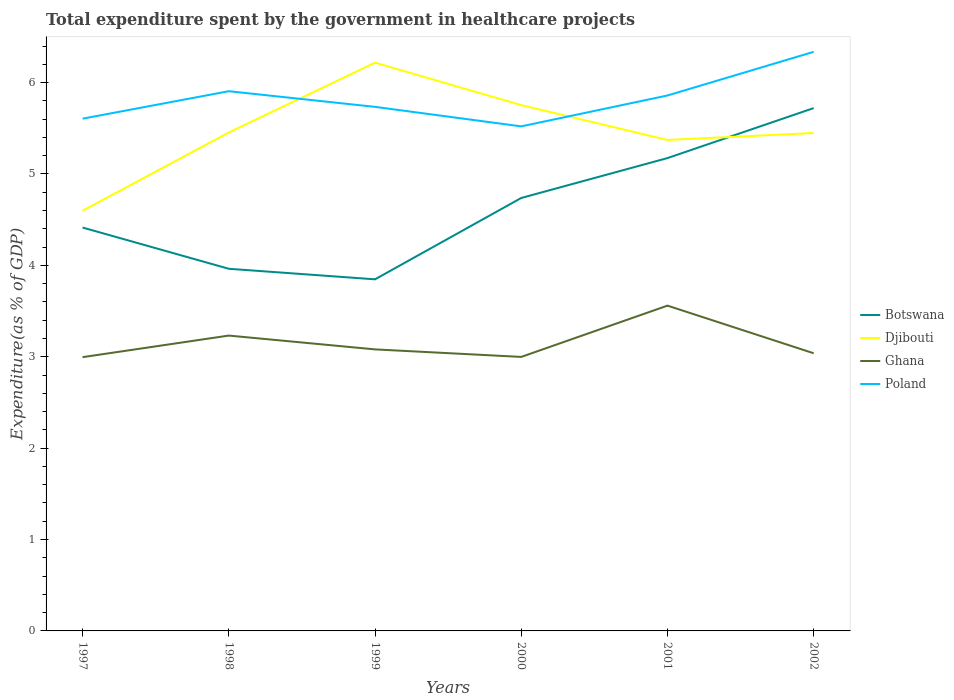How many different coloured lines are there?
Ensure brevity in your answer.  4. Does the line corresponding to Djibouti intersect with the line corresponding to Ghana?
Give a very brief answer. No. Is the number of lines equal to the number of legend labels?
Make the answer very short. Yes. Across all years, what is the maximum total expenditure spent by the government in healthcare projects in Ghana?
Provide a short and direct response. 3. In which year was the total expenditure spent by the government in healthcare projects in Poland maximum?
Your answer should be compact. 2000. What is the total total expenditure spent by the government in healthcare projects in Poland in the graph?
Make the answer very short. 0.21. What is the difference between the highest and the second highest total expenditure spent by the government in healthcare projects in Ghana?
Make the answer very short. 0.56. What is the difference between the highest and the lowest total expenditure spent by the government in healthcare projects in Ghana?
Make the answer very short. 2. Is the total expenditure spent by the government in healthcare projects in Ghana strictly greater than the total expenditure spent by the government in healthcare projects in Poland over the years?
Give a very brief answer. Yes. How many lines are there?
Give a very brief answer. 4. How many legend labels are there?
Provide a short and direct response. 4. How are the legend labels stacked?
Provide a short and direct response. Vertical. What is the title of the graph?
Keep it short and to the point. Total expenditure spent by the government in healthcare projects. Does "St. Vincent and the Grenadines" appear as one of the legend labels in the graph?
Your answer should be very brief. No. What is the label or title of the X-axis?
Make the answer very short. Years. What is the label or title of the Y-axis?
Give a very brief answer. Expenditure(as % of GDP). What is the Expenditure(as % of GDP) of Botswana in 1997?
Offer a terse response. 4.41. What is the Expenditure(as % of GDP) of Djibouti in 1997?
Ensure brevity in your answer.  4.6. What is the Expenditure(as % of GDP) in Ghana in 1997?
Give a very brief answer. 3. What is the Expenditure(as % of GDP) in Poland in 1997?
Make the answer very short. 5.61. What is the Expenditure(as % of GDP) of Botswana in 1998?
Your response must be concise. 3.96. What is the Expenditure(as % of GDP) in Djibouti in 1998?
Offer a very short reply. 5.45. What is the Expenditure(as % of GDP) of Ghana in 1998?
Your answer should be compact. 3.23. What is the Expenditure(as % of GDP) in Poland in 1998?
Make the answer very short. 5.91. What is the Expenditure(as % of GDP) of Botswana in 1999?
Offer a terse response. 3.85. What is the Expenditure(as % of GDP) of Djibouti in 1999?
Offer a terse response. 6.22. What is the Expenditure(as % of GDP) of Ghana in 1999?
Offer a terse response. 3.08. What is the Expenditure(as % of GDP) in Poland in 1999?
Offer a terse response. 5.73. What is the Expenditure(as % of GDP) in Botswana in 2000?
Provide a succinct answer. 4.74. What is the Expenditure(as % of GDP) of Djibouti in 2000?
Ensure brevity in your answer.  5.75. What is the Expenditure(as % of GDP) of Ghana in 2000?
Your answer should be compact. 3. What is the Expenditure(as % of GDP) of Poland in 2000?
Your answer should be compact. 5.52. What is the Expenditure(as % of GDP) in Botswana in 2001?
Your answer should be very brief. 5.17. What is the Expenditure(as % of GDP) in Djibouti in 2001?
Your response must be concise. 5.37. What is the Expenditure(as % of GDP) of Ghana in 2001?
Your answer should be compact. 3.56. What is the Expenditure(as % of GDP) of Poland in 2001?
Provide a succinct answer. 5.86. What is the Expenditure(as % of GDP) of Botswana in 2002?
Make the answer very short. 5.72. What is the Expenditure(as % of GDP) in Djibouti in 2002?
Provide a succinct answer. 5.45. What is the Expenditure(as % of GDP) of Ghana in 2002?
Offer a terse response. 3.04. What is the Expenditure(as % of GDP) in Poland in 2002?
Your response must be concise. 6.34. Across all years, what is the maximum Expenditure(as % of GDP) in Botswana?
Offer a terse response. 5.72. Across all years, what is the maximum Expenditure(as % of GDP) in Djibouti?
Provide a short and direct response. 6.22. Across all years, what is the maximum Expenditure(as % of GDP) of Ghana?
Give a very brief answer. 3.56. Across all years, what is the maximum Expenditure(as % of GDP) of Poland?
Ensure brevity in your answer.  6.34. Across all years, what is the minimum Expenditure(as % of GDP) of Botswana?
Give a very brief answer. 3.85. Across all years, what is the minimum Expenditure(as % of GDP) of Djibouti?
Provide a short and direct response. 4.6. Across all years, what is the minimum Expenditure(as % of GDP) in Ghana?
Offer a terse response. 3. Across all years, what is the minimum Expenditure(as % of GDP) in Poland?
Make the answer very short. 5.52. What is the total Expenditure(as % of GDP) of Botswana in the graph?
Provide a short and direct response. 27.86. What is the total Expenditure(as % of GDP) of Djibouti in the graph?
Provide a short and direct response. 32.85. What is the total Expenditure(as % of GDP) in Ghana in the graph?
Offer a very short reply. 18.9. What is the total Expenditure(as % of GDP) of Poland in the graph?
Offer a terse response. 34.96. What is the difference between the Expenditure(as % of GDP) in Botswana in 1997 and that in 1998?
Keep it short and to the point. 0.45. What is the difference between the Expenditure(as % of GDP) of Djibouti in 1997 and that in 1998?
Make the answer very short. -0.86. What is the difference between the Expenditure(as % of GDP) in Ghana in 1997 and that in 1998?
Provide a short and direct response. -0.24. What is the difference between the Expenditure(as % of GDP) of Poland in 1997 and that in 1998?
Keep it short and to the point. -0.3. What is the difference between the Expenditure(as % of GDP) in Botswana in 1997 and that in 1999?
Offer a terse response. 0.57. What is the difference between the Expenditure(as % of GDP) in Djibouti in 1997 and that in 1999?
Provide a short and direct response. -1.62. What is the difference between the Expenditure(as % of GDP) in Ghana in 1997 and that in 1999?
Your answer should be very brief. -0.08. What is the difference between the Expenditure(as % of GDP) of Poland in 1997 and that in 1999?
Offer a terse response. -0.13. What is the difference between the Expenditure(as % of GDP) in Botswana in 1997 and that in 2000?
Offer a very short reply. -0.32. What is the difference between the Expenditure(as % of GDP) in Djibouti in 1997 and that in 2000?
Offer a terse response. -1.16. What is the difference between the Expenditure(as % of GDP) of Ghana in 1997 and that in 2000?
Provide a short and direct response. -0. What is the difference between the Expenditure(as % of GDP) of Poland in 1997 and that in 2000?
Make the answer very short. 0.08. What is the difference between the Expenditure(as % of GDP) in Botswana in 1997 and that in 2001?
Your answer should be compact. -0.76. What is the difference between the Expenditure(as % of GDP) in Djibouti in 1997 and that in 2001?
Ensure brevity in your answer.  -0.77. What is the difference between the Expenditure(as % of GDP) in Ghana in 1997 and that in 2001?
Offer a very short reply. -0.56. What is the difference between the Expenditure(as % of GDP) of Poland in 1997 and that in 2001?
Give a very brief answer. -0.25. What is the difference between the Expenditure(as % of GDP) in Botswana in 1997 and that in 2002?
Provide a short and direct response. -1.31. What is the difference between the Expenditure(as % of GDP) of Djibouti in 1997 and that in 2002?
Your response must be concise. -0.85. What is the difference between the Expenditure(as % of GDP) of Ghana in 1997 and that in 2002?
Your answer should be very brief. -0.04. What is the difference between the Expenditure(as % of GDP) of Poland in 1997 and that in 2002?
Offer a very short reply. -0.73. What is the difference between the Expenditure(as % of GDP) of Botswana in 1998 and that in 1999?
Offer a very short reply. 0.12. What is the difference between the Expenditure(as % of GDP) of Djibouti in 1998 and that in 1999?
Ensure brevity in your answer.  -0.76. What is the difference between the Expenditure(as % of GDP) in Ghana in 1998 and that in 1999?
Offer a terse response. 0.15. What is the difference between the Expenditure(as % of GDP) in Poland in 1998 and that in 1999?
Offer a very short reply. 0.17. What is the difference between the Expenditure(as % of GDP) of Botswana in 1998 and that in 2000?
Your answer should be compact. -0.77. What is the difference between the Expenditure(as % of GDP) of Djibouti in 1998 and that in 2000?
Give a very brief answer. -0.3. What is the difference between the Expenditure(as % of GDP) in Ghana in 1998 and that in 2000?
Offer a terse response. 0.23. What is the difference between the Expenditure(as % of GDP) in Poland in 1998 and that in 2000?
Provide a succinct answer. 0.38. What is the difference between the Expenditure(as % of GDP) of Botswana in 1998 and that in 2001?
Offer a very short reply. -1.21. What is the difference between the Expenditure(as % of GDP) in Djibouti in 1998 and that in 2001?
Your response must be concise. 0.08. What is the difference between the Expenditure(as % of GDP) in Ghana in 1998 and that in 2001?
Provide a short and direct response. -0.33. What is the difference between the Expenditure(as % of GDP) of Poland in 1998 and that in 2001?
Ensure brevity in your answer.  0.05. What is the difference between the Expenditure(as % of GDP) of Botswana in 1998 and that in 2002?
Provide a short and direct response. -1.76. What is the difference between the Expenditure(as % of GDP) in Djibouti in 1998 and that in 2002?
Your response must be concise. 0.01. What is the difference between the Expenditure(as % of GDP) of Ghana in 1998 and that in 2002?
Offer a very short reply. 0.19. What is the difference between the Expenditure(as % of GDP) of Poland in 1998 and that in 2002?
Provide a succinct answer. -0.43. What is the difference between the Expenditure(as % of GDP) of Botswana in 1999 and that in 2000?
Provide a short and direct response. -0.89. What is the difference between the Expenditure(as % of GDP) of Djibouti in 1999 and that in 2000?
Offer a terse response. 0.46. What is the difference between the Expenditure(as % of GDP) of Ghana in 1999 and that in 2000?
Keep it short and to the point. 0.08. What is the difference between the Expenditure(as % of GDP) in Poland in 1999 and that in 2000?
Your answer should be compact. 0.21. What is the difference between the Expenditure(as % of GDP) in Botswana in 1999 and that in 2001?
Provide a short and direct response. -1.33. What is the difference between the Expenditure(as % of GDP) in Djibouti in 1999 and that in 2001?
Keep it short and to the point. 0.85. What is the difference between the Expenditure(as % of GDP) in Ghana in 1999 and that in 2001?
Provide a succinct answer. -0.48. What is the difference between the Expenditure(as % of GDP) in Poland in 1999 and that in 2001?
Provide a succinct answer. -0.12. What is the difference between the Expenditure(as % of GDP) of Botswana in 1999 and that in 2002?
Your response must be concise. -1.87. What is the difference between the Expenditure(as % of GDP) of Djibouti in 1999 and that in 2002?
Offer a terse response. 0.77. What is the difference between the Expenditure(as % of GDP) in Ghana in 1999 and that in 2002?
Make the answer very short. 0.04. What is the difference between the Expenditure(as % of GDP) of Poland in 1999 and that in 2002?
Give a very brief answer. -0.6. What is the difference between the Expenditure(as % of GDP) in Botswana in 2000 and that in 2001?
Provide a succinct answer. -0.44. What is the difference between the Expenditure(as % of GDP) in Djibouti in 2000 and that in 2001?
Provide a short and direct response. 0.38. What is the difference between the Expenditure(as % of GDP) in Ghana in 2000 and that in 2001?
Provide a succinct answer. -0.56. What is the difference between the Expenditure(as % of GDP) in Poland in 2000 and that in 2001?
Keep it short and to the point. -0.34. What is the difference between the Expenditure(as % of GDP) of Botswana in 2000 and that in 2002?
Your answer should be very brief. -0.98. What is the difference between the Expenditure(as % of GDP) of Djibouti in 2000 and that in 2002?
Make the answer very short. 0.31. What is the difference between the Expenditure(as % of GDP) in Ghana in 2000 and that in 2002?
Ensure brevity in your answer.  -0.04. What is the difference between the Expenditure(as % of GDP) in Poland in 2000 and that in 2002?
Offer a very short reply. -0.82. What is the difference between the Expenditure(as % of GDP) in Botswana in 2001 and that in 2002?
Offer a very short reply. -0.55. What is the difference between the Expenditure(as % of GDP) of Djibouti in 2001 and that in 2002?
Make the answer very short. -0.08. What is the difference between the Expenditure(as % of GDP) of Ghana in 2001 and that in 2002?
Give a very brief answer. 0.52. What is the difference between the Expenditure(as % of GDP) of Poland in 2001 and that in 2002?
Your answer should be compact. -0.48. What is the difference between the Expenditure(as % of GDP) in Botswana in 1997 and the Expenditure(as % of GDP) in Djibouti in 1998?
Your response must be concise. -1.04. What is the difference between the Expenditure(as % of GDP) of Botswana in 1997 and the Expenditure(as % of GDP) of Ghana in 1998?
Provide a succinct answer. 1.18. What is the difference between the Expenditure(as % of GDP) of Botswana in 1997 and the Expenditure(as % of GDP) of Poland in 1998?
Provide a short and direct response. -1.49. What is the difference between the Expenditure(as % of GDP) of Djibouti in 1997 and the Expenditure(as % of GDP) of Ghana in 1998?
Offer a terse response. 1.37. What is the difference between the Expenditure(as % of GDP) of Djibouti in 1997 and the Expenditure(as % of GDP) of Poland in 1998?
Provide a short and direct response. -1.31. What is the difference between the Expenditure(as % of GDP) of Ghana in 1997 and the Expenditure(as % of GDP) of Poland in 1998?
Give a very brief answer. -2.91. What is the difference between the Expenditure(as % of GDP) in Botswana in 1997 and the Expenditure(as % of GDP) in Djibouti in 1999?
Provide a short and direct response. -1.8. What is the difference between the Expenditure(as % of GDP) in Botswana in 1997 and the Expenditure(as % of GDP) in Ghana in 1999?
Ensure brevity in your answer.  1.33. What is the difference between the Expenditure(as % of GDP) of Botswana in 1997 and the Expenditure(as % of GDP) of Poland in 1999?
Offer a very short reply. -1.32. What is the difference between the Expenditure(as % of GDP) in Djibouti in 1997 and the Expenditure(as % of GDP) in Ghana in 1999?
Your response must be concise. 1.52. What is the difference between the Expenditure(as % of GDP) in Djibouti in 1997 and the Expenditure(as % of GDP) in Poland in 1999?
Keep it short and to the point. -1.14. What is the difference between the Expenditure(as % of GDP) of Ghana in 1997 and the Expenditure(as % of GDP) of Poland in 1999?
Provide a succinct answer. -2.74. What is the difference between the Expenditure(as % of GDP) of Botswana in 1997 and the Expenditure(as % of GDP) of Djibouti in 2000?
Your answer should be very brief. -1.34. What is the difference between the Expenditure(as % of GDP) of Botswana in 1997 and the Expenditure(as % of GDP) of Ghana in 2000?
Your answer should be compact. 1.42. What is the difference between the Expenditure(as % of GDP) of Botswana in 1997 and the Expenditure(as % of GDP) of Poland in 2000?
Provide a succinct answer. -1.11. What is the difference between the Expenditure(as % of GDP) in Djibouti in 1997 and the Expenditure(as % of GDP) in Ghana in 2000?
Make the answer very short. 1.6. What is the difference between the Expenditure(as % of GDP) of Djibouti in 1997 and the Expenditure(as % of GDP) of Poland in 2000?
Keep it short and to the point. -0.92. What is the difference between the Expenditure(as % of GDP) in Ghana in 1997 and the Expenditure(as % of GDP) in Poland in 2000?
Keep it short and to the point. -2.53. What is the difference between the Expenditure(as % of GDP) in Botswana in 1997 and the Expenditure(as % of GDP) in Djibouti in 2001?
Your answer should be compact. -0.96. What is the difference between the Expenditure(as % of GDP) of Botswana in 1997 and the Expenditure(as % of GDP) of Ghana in 2001?
Your answer should be compact. 0.85. What is the difference between the Expenditure(as % of GDP) of Botswana in 1997 and the Expenditure(as % of GDP) of Poland in 2001?
Ensure brevity in your answer.  -1.45. What is the difference between the Expenditure(as % of GDP) of Djibouti in 1997 and the Expenditure(as % of GDP) of Ghana in 2001?
Ensure brevity in your answer.  1.04. What is the difference between the Expenditure(as % of GDP) of Djibouti in 1997 and the Expenditure(as % of GDP) of Poland in 2001?
Provide a short and direct response. -1.26. What is the difference between the Expenditure(as % of GDP) of Ghana in 1997 and the Expenditure(as % of GDP) of Poland in 2001?
Offer a terse response. -2.86. What is the difference between the Expenditure(as % of GDP) in Botswana in 1997 and the Expenditure(as % of GDP) in Djibouti in 2002?
Your response must be concise. -1.03. What is the difference between the Expenditure(as % of GDP) of Botswana in 1997 and the Expenditure(as % of GDP) of Ghana in 2002?
Make the answer very short. 1.38. What is the difference between the Expenditure(as % of GDP) in Botswana in 1997 and the Expenditure(as % of GDP) in Poland in 2002?
Your answer should be very brief. -1.92. What is the difference between the Expenditure(as % of GDP) of Djibouti in 1997 and the Expenditure(as % of GDP) of Ghana in 2002?
Give a very brief answer. 1.56. What is the difference between the Expenditure(as % of GDP) in Djibouti in 1997 and the Expenditure(as % of GDP) in Poland in 2002?
Give a very brief answer. -1.74. What is the difference between the Expenditure(as % of GDP) of Ghana in 1997 and the Expenditure(as % of GDP) of Poland in 2002?
Ensure brevity in your answer.  -3.34. What is the difference between the Expenditure(as % of GDP) of Botswana in 1998 and the Expenditure(as % of GDP) of Djibouti in 1999?
Offer a terse response. -2.26. What is the difference between the Expenditure(as % of GDP) of Botswana in 1998 and the Expenditure(as % of GDP) of Ghana in 1999?
Provide a succinct answer. 0.88. What is the difference between the Expenditure(as % of GDP) of Botswana in 1998 and the Expenditure(as % of GDP) of Poland in 1999?
Your response must be concise. -1.77. What is the difference between the Expenditure(as % of GDP) in Djibouti in 1998 and the Expenditure(as % of GDP) in Ghana in 1999?
Provide a succinct answer. 2.37. What is the difference between the Expenditure(as % of GDP) in Djibouti in 1998 and the Expenditure(as % of GDP) in Poland in 1999?
Ensure brevity in your answer.  -0.28. What is the difference between the Expenditure(as % of GDP) in Ghana in 1998 and the Expenditure(as % of GDP) in Poland in 1999?
Provide a succinct answer. -2.5. What is the difference between the Expenditure(as % of GDP) of Botswana in 1998 and the Expenditure(as % of GDP) of Djibouti in 2000?
Keep it short and to the point. -1.79. What is the difference between the Expenditure(as % of GDP) of Botswana in 1998 and the Expenditure(as % of GDP) of Ghana in 2000?
Offer a very short reply. 0.96. What is the difference between the Expenditure(as % of GDP) of Botswana in 1998 and the Expenditure(as % of GDP) of Poland in 2000?
Give a very brief answer. -1.56. What is the difference between the Expenditure(as % of GDP) in Djibouti in 1998 and the Expenditure(as % of GDP) in Ghana in 2000?
Offer a terse response. 2.46. What is the difference between the Expenditure(as % of GDP) in Djibouti in 1998 and the Expenditure(as % of GDP) in Poland in 2000?
Your answer should be very brief. -0.07. What is the difference between the Expenditure(as % of GDP) in Ghana in 1998 and the Expenditure(as % of GDP) in Poland in 2000?
Provide a succinct answer. -2.29. What is the difference between the Expenditure(as % of GDP) in Botswana in 1998 and the Expenditure(as % of GDP) in Djibouti in 2001?
Keep it short and to the point. -1.41. What is the difference between the Expenditure(as % of GDP) in Botswana in 1998 and the Expenditure(as % of GDP) in Ghana in 2001?
Ensure brevity in your answer.  0.4. What is the difference between the Expenditure(as % of GDP) of Botswana in 1998 and the Expenditure(as % of GDP) of Poland in 2001?
Make the answer very short. -1.9. What is the difference between the Expenditure(as % of GDP) of Djibouti in 1998 and the Expenditure(as % of GDP) of Ghana in 2001?
Your response must be concise. 1.89. What is the difference between the Expenditure(as % of GDP) in Djibouti in 1998 and the Expenditure(as % of GDP) in Poland in 2001?
Your answer should be very brief. -0.4. What is the difference between the Expenditure(as % of GDP) of Ghana in 1998 and the Expenditure(as % of GDP) of Poland in 2001?
Your response must be concise. -2.63. What is the difference between the Expenditure(as % of GDP) in Botswana in 1998 and the Expenditure(as % of GDP) in Djibouti in 2002?
Give a very brief answer. -1.49. What is the difference between the Expenditure(as % of GDP) of Botswana in 1998 and the Expenditure(as % of GDP) of Ghana in 2002?
Your answer should be compact. 0.92. What is the difference between the Expenditure(as % of GDP) of Botswana in 1998 and the Expenditure(as % of GDP) of Poland in 2002?
Your answer should be very brief. -2.37. What is the difference between the Expenditure(as % of GDP) in Djibouti in 1998 and the Expenditure(as % of GDP) in Ghana in 2002?
Your response must be concise. 2.42. What is the difference between the Expenditure(as % of GDP) in Djibouti in 1998 and the Expenditure(as % of GDP) in Poland in 2002?
Offer a very short reply. -0.88. What is the difference between the Expenditure(as % of GDP) of Ghana in 1998 and the Expenditure(as % of GDP) of Poland in 2002?
Offer a very short reply. -3.1. What is the difference between the Expenditure(as % of GDP) in Botswana in 1999 and the Expenditure(as % of GDP) in Djibouti in 2000?
Give a very brief answer. -1.91. What is the difference between the Expenditure(as % of GDP) in Botswana in 1999 and the Expenditure(as % of GDP) in Ghana in 2000?
Ensure brevity in your answer.  0.85. What is the difference between the Expenditure(as % of GDP) in Botswana in 1999 and the Expenditure(as % of GDP) in Poland in 2000?
Your answer should be compact. -1.67. What is the difference between the Expenditure(as % of GDP) in Djibouti in 1999 and the Expenditure(as % of GDP) in Ghana in 2000?
Offer a very short reply. 3.22. What is the difference between the Expenditure(as % of GDP) in Djibouti in 1999 and the Expenditure(as % of GDP) in Poland in 2000?
Your answer should be compact. 0.7. What is the difference between the Expenditure(as % of GDP) in Ghana in 1999 and the Expenditure(as % of GDP) in Poland in 2000?
Your answer should be very brief. -2.44. What is the difference between the Expenditure(as % of GDP) of Botswana in 1999 and the Expenditure(as % of GDP) of Djibouti in 2001?
Your answer should be very brief. -1.53. What is the difference between the Expenditure(as % of GDP) of Botswana in 1999 and the Expenditure(as % of GDP) of Ghana in 2001?
Keep it short and to the point. 0.29. What is the difference between the Expenditure(as % of GDP) of Botswana in 1999 and the Expenditure(as % of GDP) of Poland in 2001?
Offer a terse response. -2.01. What is the difference between the Expenditure(as % of GDP) in Djibouti in 1999 and the Expenditure(as % of GDP) in Ghana in 2001?
Provide a succinct answer. 2.66. What is the difference between the Expenditure(as % of GDP) in Djibouti in 1999 and the Expenditure(as % of GDP) in Poland in 2001?
Your answer should be compact. 0.36. What is the difference between the Expenditure(as % of GDP) of Ghana in 1999 and the Expenditure(as % of GDP) of Poland in 2001?
Keep it short and to the point. -2.78. What is the difference between the Expenditure(as % of GDP) of Botswana in 1999 and the Expenditure(as % of GDP) of Djibouti in 2002?
Your response must be concise. -1.6. What is the difference between the Expenditure(as % of GDP) of Botswana in 1999 and the Expenditure(as % of GDP) of Ghana in 2002?
Your response must be concise. 0.81. What is the difference between the Expenditure(as % of GDP) in Botswana in 1999 and the Expenditure(as % of GDP) in Poland in 2002?
Your answer should be compact. -2.49. What is the difference between the Expenditure(as % of GDP) in Djibouti in 1999 and the Expenditure(as % of GDP) in Ghana in 2002?
Your answer should be compact. 3.18. What is the difference between the Expenditure(as % of GDP) in Djibouti in 1999 and the Expenditure(as % of GDP) in Poland in 2002?
Your answer should be very brief. -0.12. What is the difference between the Expenditure(as % of GDP) of Ghana in 1999 and the Expenditure(as % of GDP) of Poland in 2002?
Ensure brevity in your answer.  -3.26. What is the difference between the Expenditure(as % of GDP) of Botswana in 2000 and the Expenditure(as % of GDP) of Djibouti in 2001?
Offer a very short reply. -0.63. What is the difference between the Expenditure(as % of GDP) in Botswana in 2000 and the Expenditure(as % of GDP) in Ghana in 2001?
Keep it short and to the point. 1.18. What is the difference between the Expenditure(as % of GDP) of Botswana in 2000 and the Expenditure(as % of GDP) of Poland in 2001?
Ensure brevity in your answer.  -1.12. What is the difference between the Expenditure(as % of GDP) in Djibouti in 2000 and the Expenditure(as % of GDP) in Ghana in 2001?
Offer a terse response. 2.19. What is the difference between the Expenditure(as % of GDP) of Djibouti in 2000 and the Expenditure(as % of GDP) of Poland in 2001?
Provide a short and direct response. -0.11. What is the difference between the Expenditure(as % of GDP) of Ghana in 2000 and the Expenditure(as % of GDP) of Poland in 2001?
Make the answer very short. -2.86. What is the difference between the Expenditure(as % of GDP) of Botswana in 2000 and the Expenditure(as % of GDP) of Djibouti in 2002?
Provide a succinct answer. -0.71. What is the difference between the Expenditure(as % of GDP) of Botswana in 2000 and the Expenditure(as % of GDP) of Ghana in 2002?
Keep it short and to the point. 1.7. What is the difference between the Expenditure(as % of GDP) in Botswana in 2000 and the Expenditure(as % of GDP) in Poland in 2002?
Give a very brief answer. -1.6. What is the difference between the Expenditure(as % of GDP) in Djibouti in 2000 and the Expenditure(as % of GDP) in Ghana in 2002?
Your response must be concise. 2.72. What is the difference between the Expenditure(as % of GDP) in Djibouti in 2000 and the Expenditure(as % of GDP) in Poland in 2002?
Provide a short and direct response. -0.58. What is the difference between the Expenditure(as % of GDP) of Ghana in 2000 and the Expenditure(as % of GDP) of Poland in 2002?
Your response must be concise. -3.34. What is the difference between the Expenditure(as % of GDP) of Botswana in 2001 and the Expenditure(as % of GDP) of Djibouti in 2002?
Offer a terse response. -0.27. What is the difference between the Expenditure(as % of GDP) of Botswana in 2001 and the Expenditure(as % of GDP) of Ghana in 2002?
Make the answer very short. 2.14. What is the difference between the Expenditure(as % of GDP) of Botswana in 2001 and the Expenditure(as % of GDP) of Poland in 2002?
Keep it short and to the point. -1.16. What is the difference between the Expenditure(as % of GDP) of Djibouti in 2001 and the Expenditure(as % of GDP) of Ghana in 2002?
Ensure brevity in your answer.  2.33. What is the difference between the Expenditure(as % of GDP) in Djibouti in 2001 and the Expenditure(as % of GDP) in Poland in 2002?
Your answer should be compact. -0.96. What is the difference between the Expenditure(as % of GDP) in Ghana in 2001 and the Expenditure(as % of GDP) in Poland in 2002?
Your answer should be compact. -2.78. What is the average Expenditure(as % of GDP) of Botswana per year?
Provide a short and direct response. 4.64. What is the average Expenditure(as % of GDP) of Djibouti per year?
Provide a succinct answer. 5.47. What is the average Expenditure(as % of GDP) of Ghana per year?
Provide a succinct answer. 3.15. What is the average Expenditure(as % of GDP) in Poland per year?
Keep it short and to the point. 5.83. In the year 1997, what is the difference between the Expenditure(as % of GDP) in Botswana and Expenditure(as % of GDP) in Djibouti?
Offer a very short reply. -0.18. In the year 1997, what is the difference between the Expenditure(as % of GDP) of Botswana and Expenditure(as % of GDP) of Ghana?
Your answer should be compact. 1.42. In the year 1997, what is the difference between the Expenditure(as % of GDP) in Botswana and Expenditure(as % of GDP) in Poland?
Offer a terse response. -1.19. In the year 1997, what is the difference between the Expenditure(as % of GDP) in Djibouti and Expenditure(as % of GDP) in Ghana?
Offer a very short reply. 1.6. In the year 1997, what is the difference between the Expenditure(as % of GDP) in Djibouti and Expenditure(as % of GDP) in Poland?
Provide a succinct answer. -1.01. In the year 1997, what is the difference between the Expenditure(as % of GDP) in Ghana and Expenditure(as % of GDP) in Poland?
Provide a succinct answer. -2.61. In the year 1998, what is the difference between the Expenditure(as % of GDP) of Botswana and Expenditure(as % of GDP) of Djibouti?
Your answer should be very brief. -1.49. In the year 1998, what is the difference between the Expenditure(as % of GDP) in Botswana and Expenditure(as % of GDP) in Ghana?
Offer a terse response. 0.73. In the year 1998, what is the difference between the Expenditure(as % of GDP) of Botswana and Expenditure(as % of GDP) of Poland?
Offer a terse response. -1.94. In the year 1998, what is the difference between the Expenditure(as % of GDP) of Djibouti and Expenditure(as % of GDP) of Ghana?
Your response must be concise. 2.22. In the year 1998, what is the difference between the Expenditure(as % of GDP) in Djibouti and Expenditure(as % of GDP) in Poland?
Give a very brief answer. -0.45. In the year 1998, what is the difference between the Expenditure(as % of GDP) in Ghana and Expenditure(as % of GDP) in Poland?
Your answer should be compact. -2.67. In the year 1999, what is the difference between the Expenditure(as % of GDP) in Botswana and Expenditure(as % of GDP) in Djibouti?
Provide a short and direct response. -2.37. In the year 1999, what is the difference between the Expenditure(as % of GDP) in Botswana and Expenditure(as % of GDP) in Ghana?
Offer a terse response. 0.77. In the year 1999, what is the difference between the Expenditure(as % of GDP) of Botswana and Expenditure(as % of GDP) of Poland?
Ensure brevity in your answer.  -1.89. In the year 1999, what is the difference between the Expenditure(as % of GDP) in Djibouti and Expenditure(as % of GDP) in Ghana?
Give a very brief answer. 3.14. In the year 1999, what is the difference between the Expenditure(as % of GDP) of Djibouti and Expenditure(as % of GDP) of Poland?
Your answer should be very brief. 0.48. In the year 1999, what is the difference between the Expenditure(as % of GDP) of Ghana and Expenditure(as % of GDP) of Poland?
Offer a terse response. -2.65. In the year 2000, what is the difference between the Expenditure(as % of GDP) in Botswana and Expenditure(as % of GDP) in Djibouti?
Your response must be concise. -1.02. In the year 2000, what is the difference between the Expenditure(as % of GDP) of Botswana and Expenditure(as % of GDP) of Ghana?
Give a very brief answer. 1.74. In the year 2000, what is the difference between the Expenditure(as % of GDP) of Botswana and Expenditure(as % of GDP) of Poland?
Provide a short and direct response. -0.78. In the year 2000, what is the difference between the Expenditure(as % of GDP) in Djibouti and Expenditure(as % of GDP) in Ghana?
Ensure brevity in your answer.  2.76. In the year 2000, what is the difference between the Expenditure(as % of GDP) of Djibouti and Expenditure(as % of GDP) of Poland?
Ensure brevity in your answer.  0.23. In the year 2000, what is the difference between the Expenditure(as % of GDP) of Ghana and Expenditure(as % of GDP) of Poland?
Offer a very short reply. -2.52. In the year 2001, what is the difference between the Expenditure(as % of GDP) of Botswana and Expenditure(as % of GDP) of Djibouti?
Your answer should be compact. -0.2. In the year 2001, what is the difference between the Expenditure(as % of GDP) in Botswana and Expenditure(as % of GDP) in Ghana?
Keep it short and to the point. 1.61. In the year 2001, what is the difference between the Expenditure(as % of GDP) in Botswana and Expenditure(as % of GDP) in Poland?
Give a very brief answer. -0.69. In the year 2001, what is the difference between the Expenditure(as % of GDP) of Djibouti and Expenditure(as % of GDP) of Ghana?
Your response must be concise. 1.81. In the year 2001, what is the difference between the Expenditure(as % of GDP) of Djibouti and Expenditure(as % of GDP) of Poland?
Provide a short and direct response. -0.49. In the year 2001, what is the difference between the Expenditure(as % of GDP) of Ghana and Expenditure(as % of GDP) of Poland?
Your response must be concise. -2.3. In the year 2002, what is the difference between the Expenditure(as % of GDP) in Botswana and Expenditure(as % of GDP) in Djibouti?
Keep it short and to the point. 0.27. In the year 2002, what is the difference between the Expenditure(as % of GDP) in Botswana and Expenditure(as % of GDP) in Ghana?
Provide a succinct answer. 2.68. In the year 2002, what is the difference between the Expenditure(as % of GDP) in Botswana and Expenditure(as % of GDP) in Poland?
Offer a terse response. -0.62. In the year 2002, what is the difference between the Expenditure(as % of GDP) in Djibouti and Expenditure(as % of GDP) in Ghana?
Provide a succinct answer. 2.41. In the year 2002, what is the difference between the Expenditure(as % of GDP) of Djibouti and Expenditure(as % of GDP) of Poland?
Keep it short and to the point. -0.89. In the year 2002, what is the difference between the Expenditure(as % of GDP) of Ghana and Expenditure(as % of GDP) of Poland?
Keep it short and to the point. -3.3. What is the ratio of the Expenditure(as % of GDP) in Botswana in 1997 to that in 1998?
Make the answer very short. 1.11. What is the ratio of the Expenditure(as % of GDP) in Djibouti in 1997 to that in 1998?
Offer a very short reply. 0.84. What is the ratio of the Expenditure(as % of GDP) in Ghana in 1997 to that in 1998?
Your answer should be very brief. 0.93. What is the ratio of the Expenditure(as % of GDP) in Poland in 1997 to that in 1998?
Your answer should be very brief. 0.95. What is the ratio of the Expenditure(as % of GDP) of Botswana in 1997 to that in 1999?
Your response must be concise. 1.15. What is the ratio of the Expenditure(as % of GDP) in Djibouti in 1997 to that in 1999?
Offer a very short reply. 0.74. What is the ratio of the Expenditure(as % of GDP) of Ghana in 1997 to that in 1999?
Give a very brief answer. 0.97. What is the ratio of the Expenditure(as % of GDP) of Poland in 1997 to that in 1999?
Provide a short and direct response. 0.98. What is the ratio of the Expenditure(as % of GDP) in Botswana in 1997 to that in 2000?
Provide a short and direct response. 0.93. What is the ratio of the Expenditure(as % of GDP) of Djibouti in 1997 to that in 2000?
Your response must be concise. 0.8. What is the ratio of the Expenditure(as % of GDP) of Ghana in 1997 to that in 2000?
Offer a terse response. 1. What is the ratio of the Expenditure(as % of GDP) of Poland in 1997 to that in 2000?
Your answer should be very brief. 1.02. What is the ratio of the Expenditure(as % of GDP) of Botswana in 1997 to that in 2001?
Your answer should be very brief. 0.85. What is the ratio of the Expenditure(as % of GDP) of Djibouti in 1997 to that in 2001?
Offer a terse response. 0.86. What is the ratio of the Expenditure(as % of GDP) in Ghana in 1997 to that in 2001?
Keep it short and to the point. 0.84. What is the ratio of the Expenditure(as % of GDP) of Poland in 1997 to that in 2001?
Your answer should be very brief. 0.96. What is the ratio of the Expenditure(as % of GDP) in Botswana in 1997 to that in 2002?
Provide a succinct answer. 0.77. What is the ratio of the Expenditure(as % of GDP) of Djibouti in 1997 to that in 2002?
Your answer should be compact. 0.84. What is the ratio of the Expenditure(as % of GDP) in Poland in 1997 to that in 2002?
Give a very brief answer. 0.88. What is the ratio of the Expenditure(as % of GDP) of Djibouti in 1998 to that in 1999?
Give a very brief answer. 0.88. What is the ratio of the Expenditure(as % of GDP) of Ghana in 1998 to that in 1999?
Your response must be concise. 1.05. What is the ratio of the Expenditure(as % of GDP) of Poland in 1998 to that in 1999?
Your answer should be compact. 1.03. What is the ratio of the Expenditure(as % of GDP) in Botswana in 1998 to that in 2000?
Your response must be concise. 0.84. What is the ratio of the Expenditure(as % of GDP) of Djibouti in 1998 to that in 2000?
Your answer should be compact. 0.95. What is the ratio of the Expenditure(as % of GDP) of Ghana in 1998 to that in 2000?
Your answer should be very brief. 1.08. What is the ratio of the Expenditure(as % of GDP) of Poland in 1998 to that in 2000?
Offer a very short reply. 1.07. What is the ratio of the Expenditure(as % of GDP) of Botswana in 1998 to that in 2001?
Provide a succinct answer. 0.77. What is the ratio of the Expenditure(as % of GDP) of Djibouti in 1998 to that in 2001?
Offer a very short reply. 1.02. What is the ratio of the Expenditure(as % of GDP) of Ghana in 1998 to that in 2001?
Ensure brevity in your answer.  0.91. What is the ratio of the Expenditure(as % of GDP) of Poland in 1998 to that in 2001?
Make the answer very short. 1.01. What is the ratio of the Expenditure(as % of GDP) in Botswana in 1998 to that in 2002?
Offer a very short reply. 0.69. What is the ratio of the Expenditure(as % of GDP) in Ghana in 1998 to that in 2002?
Your response must be concise. 1.06. What is the ratio of the Expenditure(as % of GDP) in Poland in 1998 to that in 2002?
Keep it short and to the point. 0.93. What is the ratio of the Expenditure(as % of GDP) of Botswana in 1999 to that in 2000?
Make the answer very short. 0.81. What is the ratio of the Expenditure(as % of GDP) in Djibouti in 1999 to that in 2000?
Ensure brevity in your answer.  1.08. What is the ratio of the Expenditure(as % of GDP) in Ghana in 1999 to that in 2000?
Make the answer very short. 1.03. What is the ratio of the Expenditure(as % of GDP) of Poland in 1999 to that in 2000?
Your answer should be compact. 1.04. What is the ratio of the Expenditure(as % of GDP) in Botswana in 1999 to that in 2001?
Give a very brief answer. 0.74. What is the ratio of the Expenditure(as % of GDP) in Djibouti in 1999 to that in 2001?
Your response must be concise. 1.16. What is the ratio of the Expenditure(as % of GDP) of Ghana in 1999 to that in 2001?
Offer a very short reply. 0.87. What is the ratio of the Expenditure(as % of GDP) in Poland in 1999 to that in 2001?
Your answer should be very brief. 0.98. What is the ratio of the Expenditure(as % of GDP) in Botswana in 1999 to that in 2002?
Your response must be concise. 0.67. What is the ratio of the Expenditure(as % of GDP) in Djibouti in 1999 to that in 2002?
Offer a terse response. 1.14. What is the ratio of the Expenditure(as % of GDP) of Ghana in 1999 to that in 2002?
Your answer should be very brief. 1.01. What is the ratio of the Expenditure(as % of GDP) in Poland in 1999 to that in 2002?
Provide a succinct answer. 0.91. What is the ratio of the Expenditure(as % of GDP) in Botswana in 2000 to that in 2001?
Provide a succinct answer. 0.92. What is the ratio of the Expenditure(as % of GDP) in Djibouti in 2000 to that in 2001?
Offer a terse response. 1.07. What is the ratio of the Expenditure(as % of GDP) in Ghana in 2000 to that in 2001?
Offer a terse response. 0.84. What is the ratio of the Expenditure(as % of GDP) of Poland in 2000 to that in 2001?
Offer a very short reply. 0.94. What is the ratio of the Expenditure(as % of GDP) in Botswana in 2000 to that in 2002?
Ensure brevity in your answer.  0.83. What is the ratio of the Expenditure(as % of GDP) in Djibouti in 2000 to that in 2002?
Offer a terse response. 1.06. What is the ratio of the Expenditure(as % of GDP) of Ghana in 2000 to that in 2002?
Give a very brief answer. 0.99. What is the ratio of the Expenditure(as % of GDP) in Poland in 2000 to that in 2002?
Ensure brevity in your answer.  0.87. What is the ratio of the Expenditure(as % of GDP) in Botswana in 2001 to that in 2002?
Give a very brief answer. 0.9. What is the ratio of the Expenditure(as % of GDP) in Djibouti in 2001 to that in 2002?
Your response must be concise. 0.99. What is the ratio of the Expenditure(as % of GDP) in Ghana in 2001 to that in 2002?
Your response must be concise. 1.17. What is the ratio of the Expenditure(as % of GDP) in Poland in 2001 to that in 2002?
Your response must be concise. 0.92. What is the difference between the highest and the second highest Expenditure(as % of GDP) in Botswana?
Make the answer very short. 0.55. What is the difference between the highest and the second highest Expenditure(as % of GDP) of Djibouti?
Keep it short and to the point. 0.46. What is the difference between the highest and the second highest Expenditure(as % of GDP) of Ghana?
Offer a terse response. 0.33. What is the difference between the highest and the second highest Expenditure(as % of GDP) in Poland?
Your answer should be very brief. 0.43. What is the difference between the highest and the lowest Expenditure(as % of GDP) of Botswana?
Ensure brevity in your answer.  1.87. What is the difference between the highest and the lowest Expenditure(as % of GDP) of Djibouti?
Keep it short and to the point. 1.62. What is the difference between the highest and the lowest Expenditure(as % of GDP) of Ghana?
Provide a short and direct response. 0.56. What is the difference between the highest and the lowest Expenditure(as % of GDP) in Poland?
Your response must be concise. 0.82. 